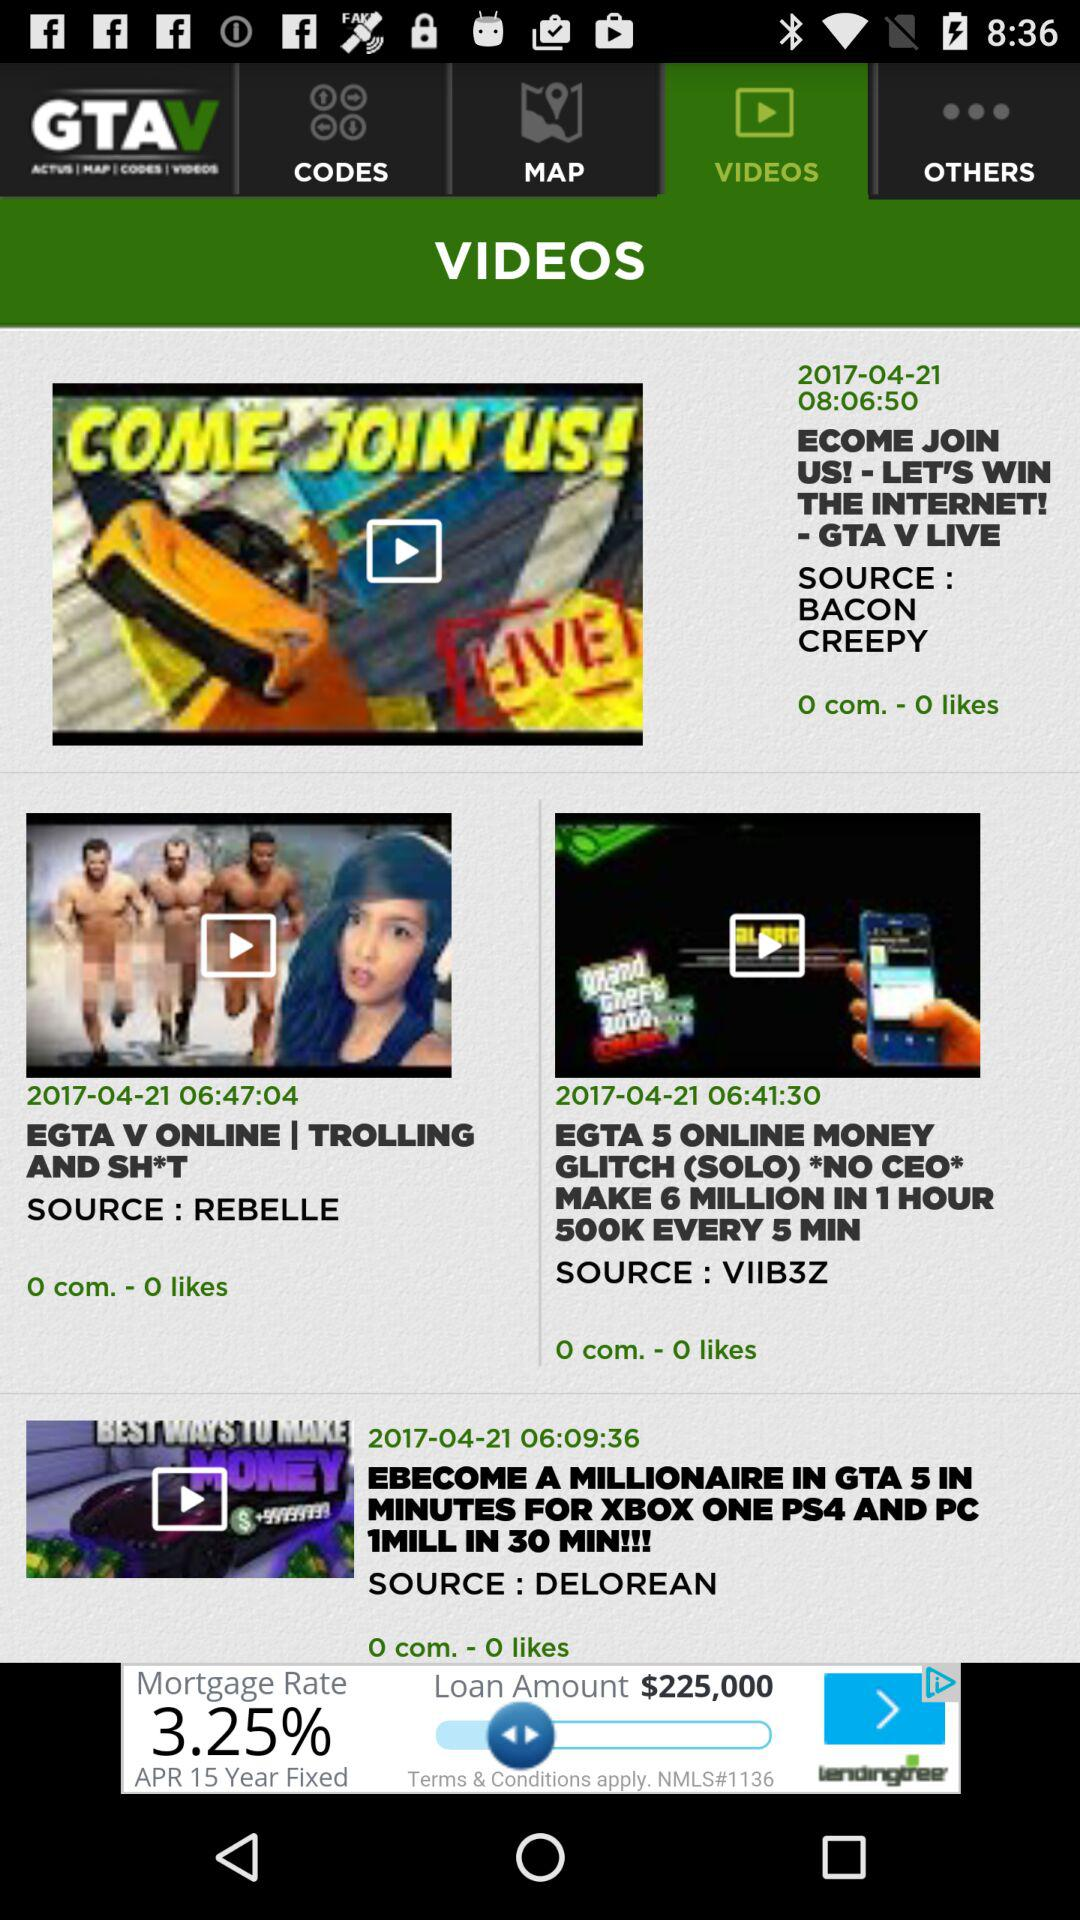Which tab is selected? The selected tab is "VIDEOS". 